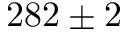Convert formula to latex. <formula><loc_0><loc_0><loc_500><loc_500>2 8 2 \pm 2</formula> 